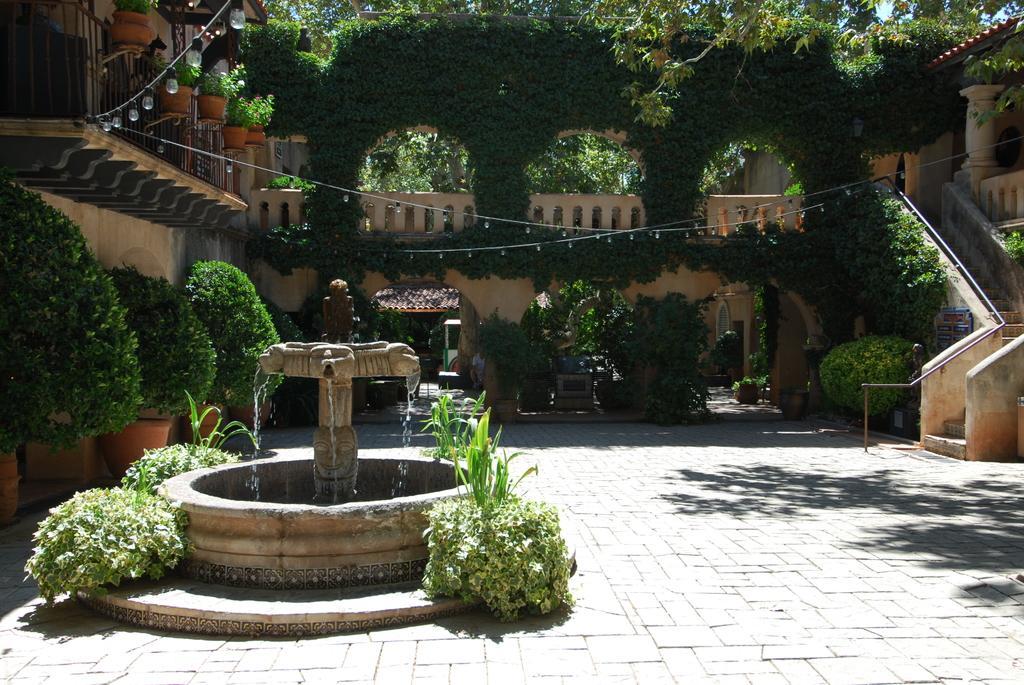Can you describe this image briefly? In this picture we can see the trees, buildings, plants, water fountain, stairs. We can see the posts and lights. 